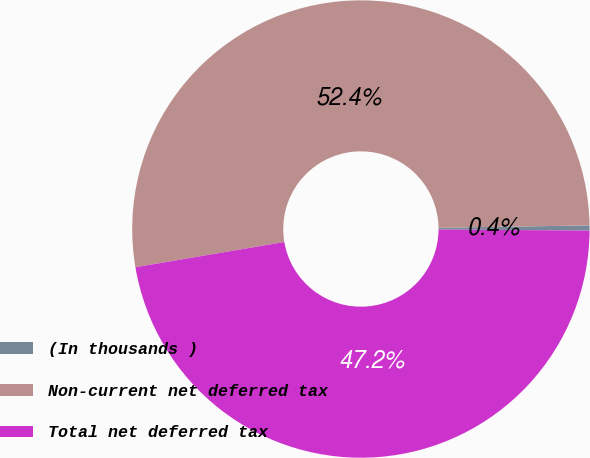Convert chart. <chart><loc_0><loc_0><loc_500><loc_500><pie_chart><fcel>(In thousands )<fcel>Non-current net deferred tax<fcel>Total net deferred tax<nl><fcel>0.36%<fcel>52.42%<fcel>47.22%<nl></chart> 